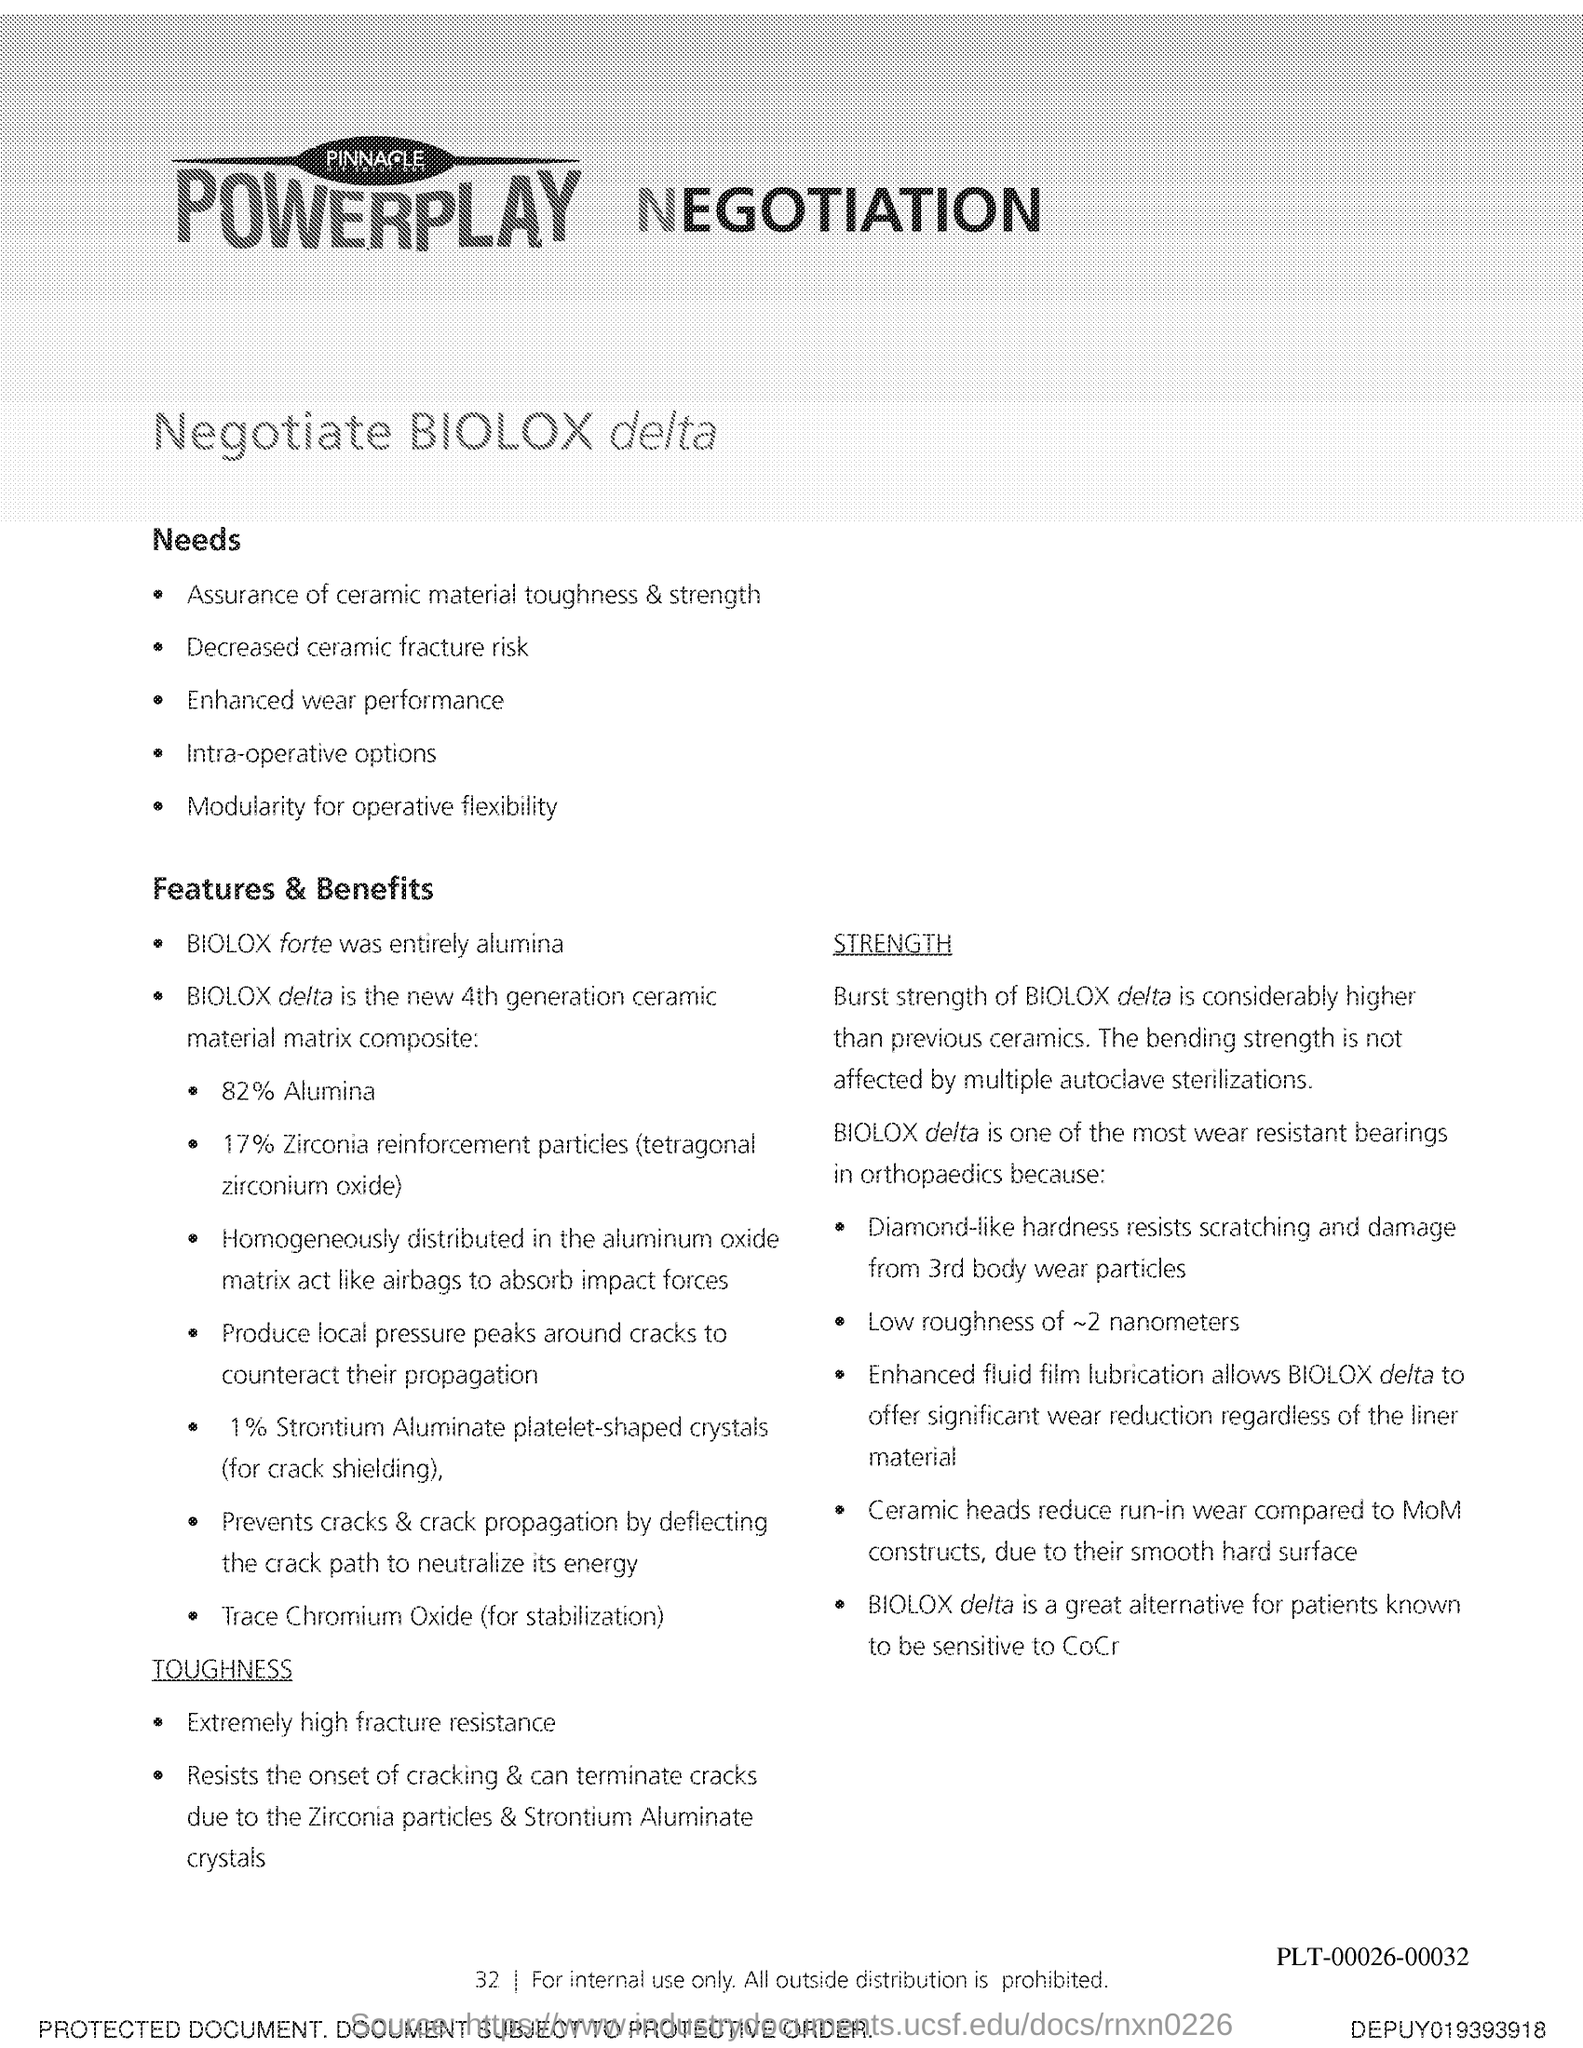What is the Page Number?
Ensure brevity in your answer.  32. 